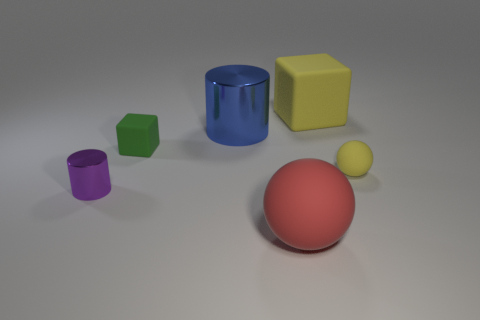Add 2 small brown metal cubes. How many objects exist? 8 Subtract all cylinders. How many objects are left? 4 Add 6 large yellow matte cubes. How many large yellow matte cubes are left? 7 Add 4 cyan rubber cubes. How many cyan rubber cubes exist? 4 Subtract 0 yellow cylinders. How many objects are left? 6 Subtract all tiny spheres. Subtract all yellow cubes. How many objects are left? 4 